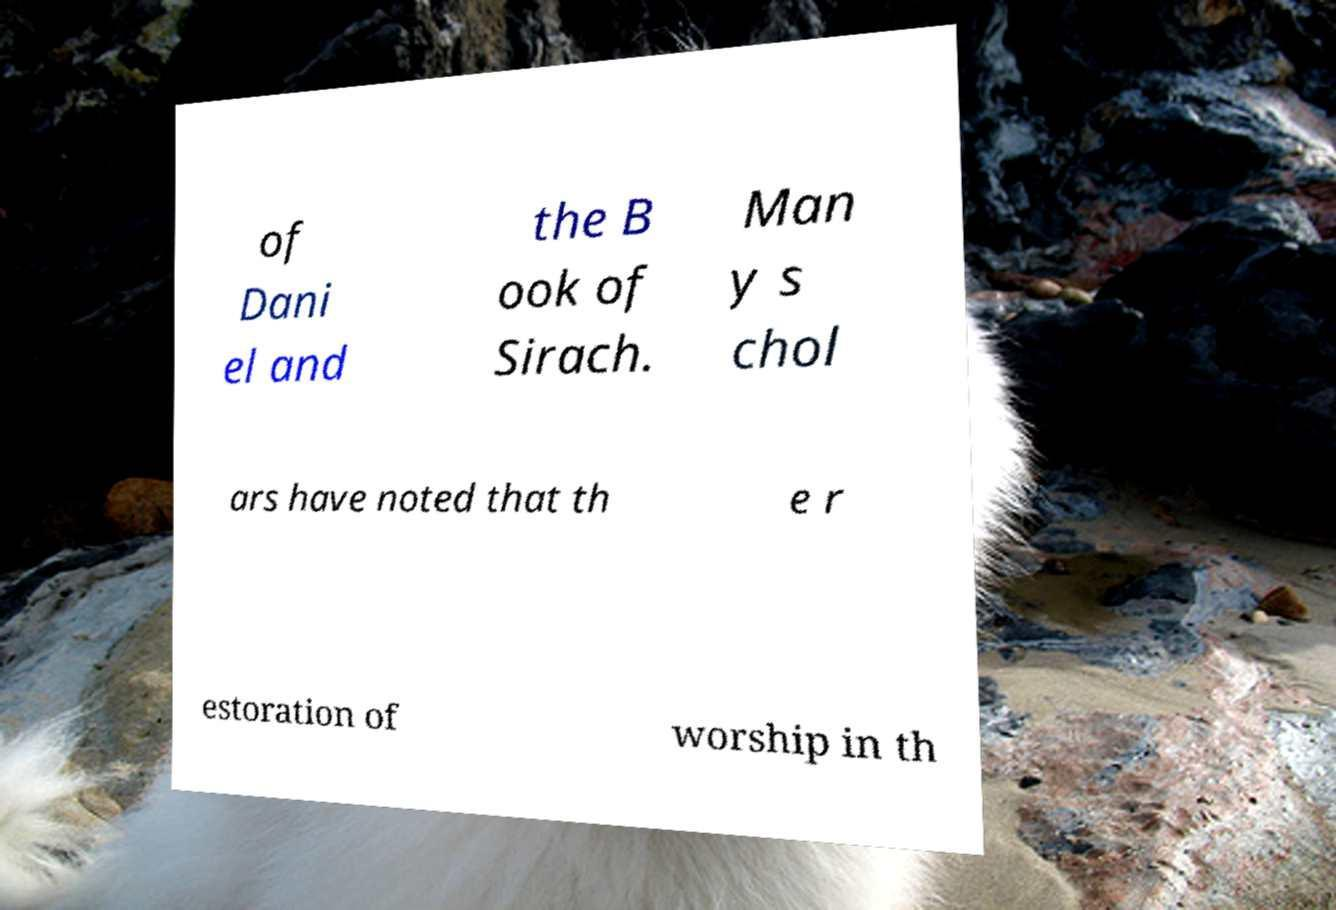Could you extract and type out the text from this image? of Dani el and the B ook of Sirach. Man y s chol ars have noted that th e r estoration of worship in th 